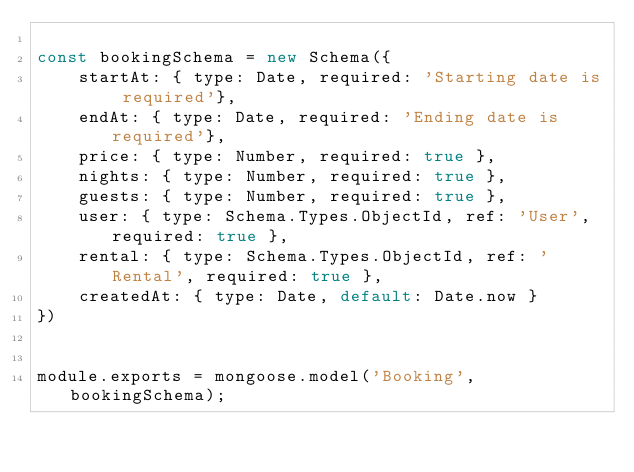Convert code to text. <code><loc_0><loc_0><loc_500><loc_500><_JavaScript_>
const bookingSchema = new Schema({
    startAt: { type: Date, required: 'Starting date is required'},
    endAt: { type: Date, required: 'Ending date is required'},
    price: { type: Number, required: true },
    nights: { type: Number, required: true },
    guests: { type: Number, required: true },
    user: { type: Schema.Types.ObjectId, ref: 'User', required: true },
    rental: { type: Schema.Types.ObjectId, ref: 'Rental', required: true },
    createdAt: { type: Date, default: Date.now }
})


module.exports = mongoose.model('Booking', bookingSchema); </code> 